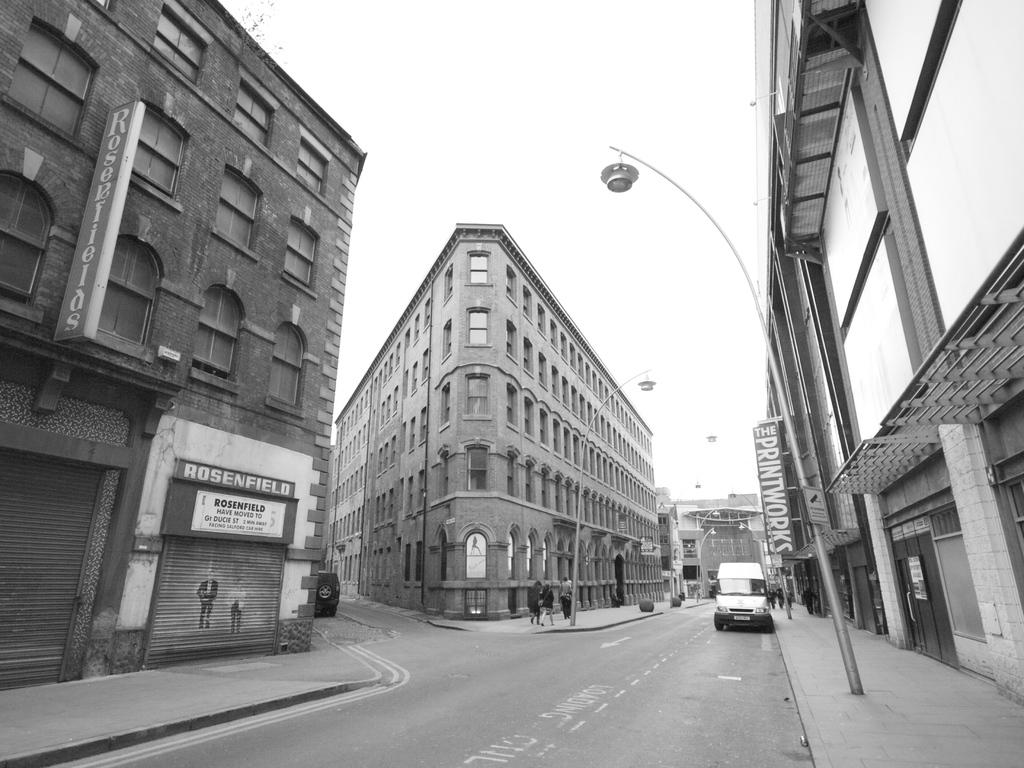<image>
Describe the image concisely. A building made of brick with a sign that says Rosenfield has moved. 